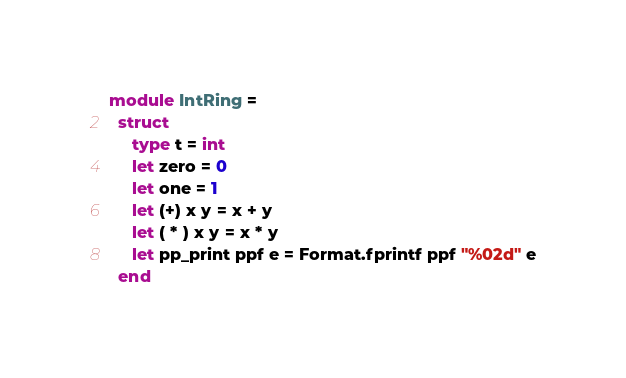Convert code to text. <code><loc_0><loc_0><loc_500><loc_500><_OCaml_>module IntRing =
  struct
     type t = int
     let zero = 0
     let one = 1
     let (+) x y = x + y
     let ( * ) x y = x * y
     let pp_print ppf e = Format.fprintf ppf "%02d" e
  end
</code> 